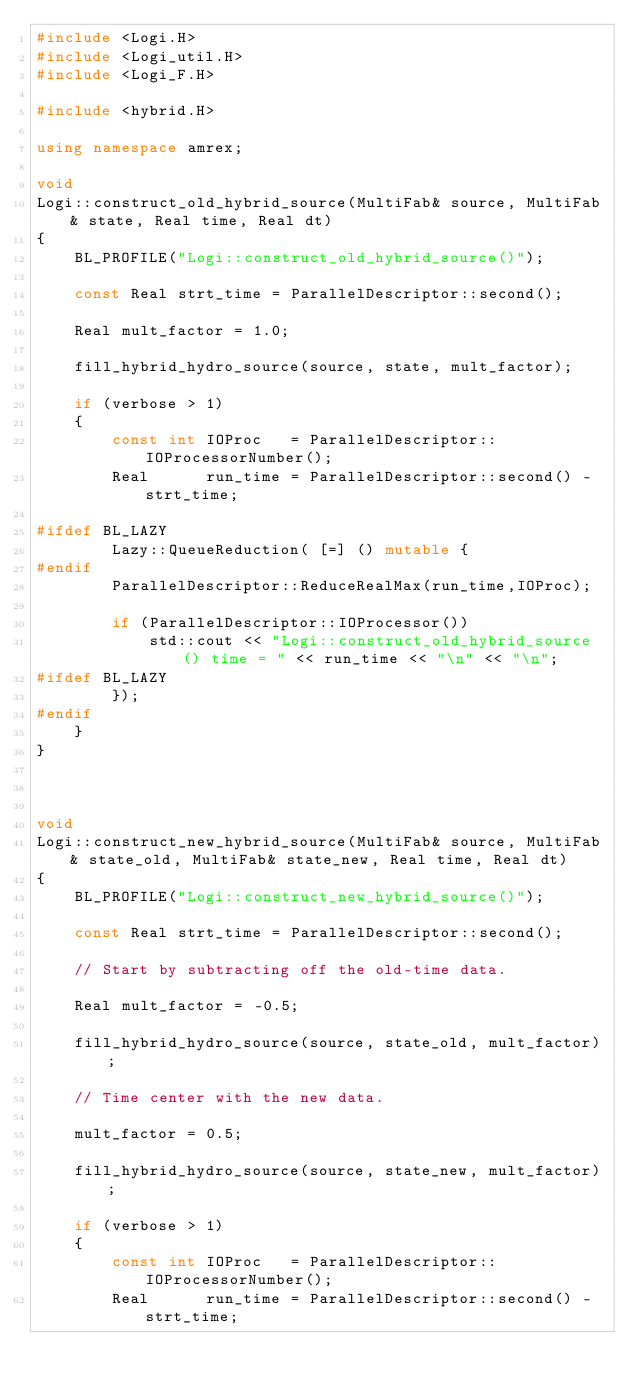<code> <loc_0><loc_0><loc_500><loc_500><_C++_>#include <Logi.H>
#include <Logi_util.H>
#include <Logi_F.H>

#include <hybrid.H>

using namespace amrex;

void
Logi::construct_old_hybrid_source(MultiFab& source, MultiFab& state, Real time, Real dt)
{
    BL_PROFILE("Logi::construct_old_hybrid_source()");

    const Real strt_time = ParallelDescriptor::second();

    Real mult_factor = 1.0;

    fill_hybrid_hydro_source(source, state, mult_factor);

    if (verbose > 1)
    {
        const int IOProc   = ParallelDescriptor::IOProcessorNumber();
        Real      run_time = ParallelDescriptor::second() - strt_time;

#ifdef BL_LAZY
        Lazy::QueueReduction( [=] () mutable {
#endif
        ParallelDescriptor::ReduceRealMax(run_time,IOProc);

        if (ParallelDescriptor::IOProcessor())
            std::cout << "Logi::construct_old_hybrid_source() time = " << run_time << "\n" << "\n";
#ifdef BL_LAZY
        });
#endif
    }
}



void
Logi::construct_new_hybrid_source(MultiFab& source, MultiFab& state_old, MultiFab& state_new, Real time, Real dt)
{
    BL_PROFILE("Logi::construct_new_hybrid_source()");

    const Real strt_time = ParallelDescriptor::second();

    // Start by subtracting off the old-time data.

    Real mult_factor = -0.5;

    fill_hybrid_hydro_source(source, state_old, mult_factor);

    // Time center with the new data.

    mult_factor = 0.5;

    fill_hybrid_hydro_source(source, state_new, mult_factor);

    if (verbose > 1)
    {
        const int IOProc   = ParallelDescriptor::IOProcessorNumber();
        Real      run_time = ParallelDescriptor::second() - strt_time;
</code> 